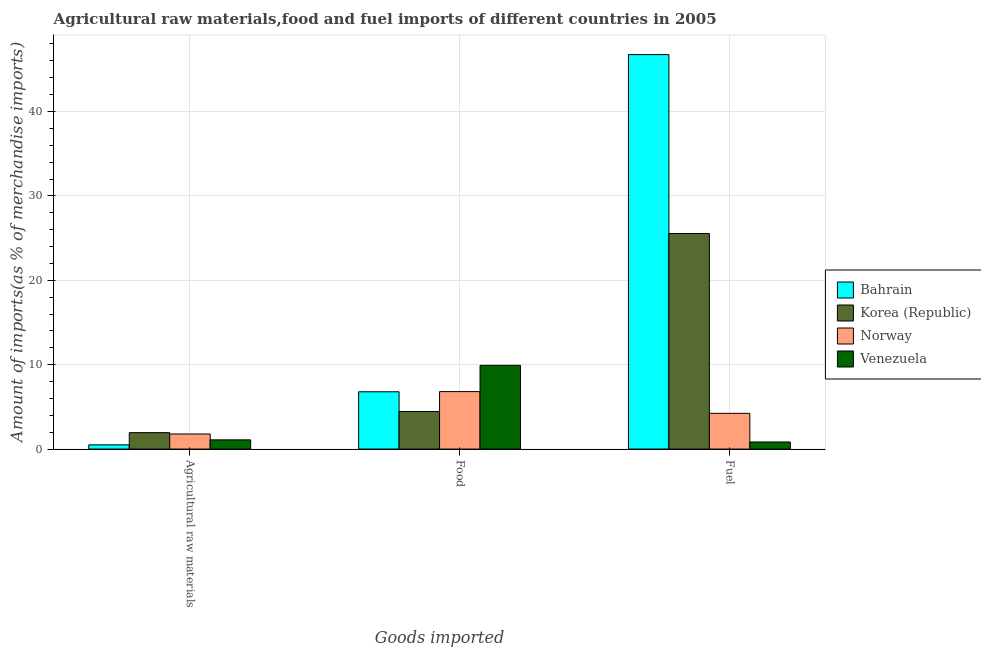How many groups of bars are there?
Keep it short and to the point. 3. How many bars are there on the 2nd tick from the right?
Offer a very short reply. 4. What is the label of the 1st group of bars from the left?
Your response must be concise. Agricultural raw materials. What is the percentage of raw materials imports in Bahrain?
Offer a terse response. 0.5. Across all countries, what is the maximum percentage of fuel imports?
Make the answer very short. 46.74. Across all countries, what is the minimum percentage of fuel imports?
Provide a short and direct response. 0.84. In which country was the percentage of food imports maximum?
Your answer should be very brief. Venezuela. In which country was the percentage of raw materials imports minimum?
Give a very brief answer. Bahrain. What is the total percentage of fuel imports in the graph?
Ensure brevity in your answer.  77.36. What is the difference between the percentage of raw materials imports in Norway and that in Bahrain?
Your response must be concise. 1.29. What is the difference between the percentage of food imports in Bahrain and the percentage of raw materials imports in Venezuela?
Make the answer very short. 5.7. What is the average percentage of food imports per country?
Offer a very short reply. 6.99. What is the difference between the percentage of food imports and percentage of raw materials imports in Norway?
Give a very brief answer. 5.02. In how many countries, is the percentage of raw materials imports greater than 32 %?
Offer a very short reply. 0. What is the ratio of the percentage of raw materials imports in Bahrain to that in Korea (Republic)?
Make the answer very short. 0.26. Is the percentage of raw materials imports in Venezuela less than that in Korea (Republic)?
Provide a short and direct response. Yes. Is the difference between the percentage of raw materials imports in Norway and Korea (Republic) greater than the difference between the percentage of fuel imports in Norway and Korea (Republic)?
Provide a succinct answer. Yes. What is the difference between the highest and the second highest percentage of food imports?
Provide a succinct answer. 3.11. What is the difference between the highest and the lowest percentage of fuel imports?
Ensure brevity in your answer.  45.9. In how many countries, is the percentage of fuel imports greater than the average percentage of fuel imports taken over all countries?
Provide a succinct answer. 2. What does the 4th bar from the left in Agricultural raw materials represents?
Give a very brief answer. Venezuela. How many bars are there?
Your response must be concise. 12. Are all the bars in the graph horizontal?
Give a very brief answer. No. How many countries are there in the graph?
Keep it short and to the point. 4. Are the values on the major ticks of Y-axis written in scientific E-notation?
Provide a short and direct response. No. Does the graph contain any zero values?
Offer a terse response. No. How many legend labels are there?
Ensure brevity in your answer.  4. How are the legend labels stacked?
Provide a short and direct response. Vertical. What is the title of the graph?
Offer a terse response. Agricultural raw materials,food and fuel imports of different countries in 2005. What is the label or title of the X-axis?
Provide a short and direct response. Goods imported. What is the label or title of the Y-axis?
Provide a short and direct response. Amount of imports(as % of merchandise imports). What is the Amount of imports(as % of merchandise imports) of Bahrain in Agricultural raw materials?
Keep it short and to the point. 0.5. What is the Amount of imports(as % of merchandise imports) in Korea (Republic) in Agricultural raw materials?
Ensure brevity in your answer.  1.95. What is the Amount of imports(as % of merchandise imports) in Norway in Agricultural raw materials?
Your answer should be compact. 1.79. What is the Amount of imports(as % of merchandise imports) in Venezuela in Agricultural raw materials?
Provide a short and direct response. 1.09. What is the Amount of imports(as % of merchandise imports) in Bahrain in Food?
Provide a succinct answer. 6.79. What is the Amount of imports(as % of merchandise imports) of Korea (Republic) in Food?
Provide a succinct answer. 4.45. What is the Amount of imports(as % of merchandise imports) in Norway in Food?
Offer a terse response. 6.81. What is the Amount of imports(as % of merchandise imports) in Venezuela in Food?
Offer a very short reply. 9.92. What is the Amount of imports(as % of merchandise imports) in Bahrain in Fuel?
Offer a terse response. 46.74. What is the Amount of imports(as % of merchandise imports) in Korea (Republic) in Fuel?
Offer a terse response. 25.54. What is the Amount of imports(as % of merchandise imports) of Norway in Fuel?
Make the answer very short. 4.24. What is the Amount of imports(as % of merchandise imports) in Venezuela in Fuel?
Your answer should be compact. 0.84. Across all Goods imported, what is the maximum Amount of imports(as % of merchandise imports) of Bahrain?
Offer a very short reply. 46.74. Across all Goods imported, what is the maximum Amount of imports(as % of merchandise imports) of Korea (Republic)?
Ensure brevity in your answer.  25.54. Across all Goods imported, what is the maximum Amount of imports(as % of merchandise imports) of Norway?
Provide a short and direct response. 6.81. Across all Goods imported, what is the maximum Amount of imports(as % of merchandise imports) of Venezuela?
Give a very brief answer. 9.92. Across all Goods imported, what is the minimum Amount of imports(as % of merchandise imports) of Bahrain?
Offer a very short reply. 0.5. Across all Goods imported, what is the minimum Amount of imports(as % of merchandise imports) in Korea (Republic)?
Provide a short and direct response. 1.95. Across all Goods imported, what is the minimum Amount of imports(as % of merchandise imports) in Norway?
Provide a short and direct response. 1.79. Across all Goods imported, what is the minimum Amount of imports(as % of merchandise imports) in Venezuela?
Your answer should be very brief. 0.84. What is the total Amount of imports(as % of merchandise imports) of Bahrain in the graph?
Keep it short and to the point. 54.03. What is the total Amount of imports(as % of merchandise imports) in Korea (Republic) in the graph?
Offer a terse response. 31.95. What is the total Amount of imports(as % of merchandise imports) of Norway in the graph?
Give a very brief answer. 12.83. What is the total Amount of imports(as % of merchandise imports) of Venezuela in the graph?
Give a very brief answer. 11.86. What is the difference between the Amount of imports(as % of merchandise imports) of Bahrain in Agricultural raw materials and that in Food?
Your answer should be compact. -6.29. What is the difference between the Amount of imports(as % of merchandise imports) of Korea (Republic) in Agricultural raw materials and that in Food?
Provide a short and direct response. -2.51. What is the difference between the Amount of imports(as % of merchandise imports) in Norway in Agricultural raw materials and that in Food?
Offer a terse response. -5.02. What is the difference between the Amount of imports(as % of merchandise imports) of Venezuela in Agricultural raw materials and that in Food?
Provide a succinct answer. -8.83. What is the difference between the Amount of imports(as % of merchandise imports) of Bahrain in Agricultural raw materials and that in Fuel?
Ensure brevity in your answer.  -46.24. What is the difference between the Amount of imports(as % of merchandise imports) in Korea (Republic) in Agricultural raw materials and that in Fuel?
Your response must be concise. -23.6. What is the difference between the Amount of imports(as % of merchandise imports) in Norway in Agricultural raw materials and that in Fuel?
Keep it short and to the point. -2.45. What is the difference between the Amount of imports(as % of merchandise imports) of Venezuela in Agricultural raw materials and that in Fuel?
Offer a very short reply. 0.25. What is the difference between the Amount of imports(as % of merchandise imports) in Bahrain in Food and that in Fuel?
Offer a very short reply. -39.95. What is the difference between the Amount of imports(as % of merchandise imports) in Korea (Republic) in Food and that in Fuel?
Make the answer very short. -21.09. What is the difference between the Amount of imports(as % of merchandise imports) of Norway in Food and that in Fuel?
Keep it short and to the point. 2.58. What is the difference between the Amount of imports(as % of merchandise imports) in Venezuela in Food and that in Fuel?
Offer a very short reply. 9.08. What is the difference between the Amount of imports(as % of merchandise imports) of Bahrain in Agricultural raw materials and the Amount of imports(as % of merchandise imports) of Korea (Republic) in Food?
Your answer should be very brief. -3.95. What is the difference between the Amount of imports(as % of merchandise imports) of Bahrain in Agricultural raw materials and the Amount of imports(as % of merchandise imports) of Norway in Food?
Your response must be concise. -6.31. What is the difference between the Amount of imports(as % of merchandise imports) in Bahrain in Agricultural raw materials and the Amount of imports(as % of merchandise imports) in Venezuela in Food?
Keep it short and to the point. -9.42. What is the difference between the Amount of imports(as % of merchandise imports) of Korea (Republic) in Agricultural raw materials and the Amount of imports(as % of merchandise imports) of Norway in Food?
Keep it short and to the point. -4.86. What is the difference between the Amount of imports(as % of merchandise imports) of Korea (Republic) in Agricultural raw materials and the Amount of imports(as % of merchandise imports) of Venezuela in Food?
Ensure brevity in your answer.  -7.97. What is the difference between the Amount of imports(as % of merchandise imports) in Norway in Agricultural raw materials and the Amount of imports(as % of merchandise imports) in Venezuela in Food?
Offer a terse response. -8.14. What is the difference between the Amount of imports(as % of merchandise imports) of Bahrain in Agricultural raw materials and the Amount of imports(as % of merchandise imports) of Korea (Republic) in Fuel?
Provide a short and direct response. -25.04. What is the difference between the Amount of imports(as % of merchandise imports) of Bahrain in Agricultural raw materials and the Amount of imports(as % of merchandise imports) of Norway in Fuel?
Make the answer very short. -3.73. What is the difference between the Amount of imports(as % of merchandise imports) of Bahrain in Agricultural raw materials and the Amount of imports(as % of merchandise imports) of Venezuela in Fuel?
Provide a succinct answer. -0.34. What is the difference between the Amount of imports(as % of merchandise imports) in Korea (Republic) in Agricultural raw materials and the Amount of imports(as % of merchandise imports) in Norway in Fuel?
Provide a short and direct response. -2.29. What is the difference between the Amount of imports(as % of merchandise imports) of Korea (Republic) in Agricultural raw materials and the Amount of imports(as % of merchandise imports) of Venezuela in Fuel?
Provide a succinct answer. 1.11. What is the difference between the Amount of imports(as % of merchandise imports) in Norway in Agricultural raw materials and the Amount of imports(as % of merchandise imports) in Venezuela in Fuel?
Keep it short and to the point. 0.95. What is the difference between the Amount of imports(as % of merchandise imports) in Bahrain in Food and the Amount of imports(as % of merchandise imports) in Korea (Republic) in Fuel?
Ensure brevity in your answer.  -18.75. What is the difference between the Amount of imports(as % of merchandise imports) of Bahrain in Food and the Amount of imports(as % of merchandise imports) of Norway in Fuel?
Offer a very short reply. 2.55. What is the difference between the Amount of imports(as % of merchandise imports) of Bahrain in Food and the Amount of imports(as % of merchandise imports) of Venezuela in Fuel?
Your response must be concise. 5.95. What is the difference between the Amount of imports(as % of merchandise imports) of Korea (Republic) in Food and the Amount of imports(as % of merchandise imports) of Norway in Fuel?
Ensure brevity in your answer.  0.22. What is the difference between the Amount of imports(as % of merchandise imports) of Korea (Republic) in Food and the Amount of imports(as % of merchandise imports) of Venezuela in Fuel?
Your answer should be compact. 3.61. What is the difference between the Amount of imports(as % of merchandise imports) in Norway in Food and the Amount of imports(as % of merchandise imports) in Venezuela in Fuel?
Make the answer very short. 5.97. What is the average Amount of imports(as % of merchandise imports) of Bahrain per Goods imported?
Offer a very short reply. 18.01. What is the average Amount of imports(as % of merchandise imports) in Korea (Republic) per Goods imported?
Ensure brevity in your answer.  10.65. What is the average Amount of imports(as % of merchandise imports) in Norway per Goods imported?
Offer a terse response. 4.28. What is the average Amount of imports(as % of merchandise imports) in Venezuela per Goods imported?
Your answer should be very brief. 3.95. What is the difference between the Amount of imports(as % of merchandise imports) of Bahrain and Amount of imports(as % of merchandise imports) of Korea (Republic) in Agricultural raw materials?
Provide a succinct answer. -1.45. What is the difference between the Amount of imports(as % of merchandise imports) of Bahrain and Amount of imports(as % of merchandise imports) of Norway in Agricultural raw materials?
Your response must be concise. -1.29. What is the difference between the Amount of imports(as % of merchandise imports) in Bahrain and Amount of imports(as % of merchandise imports) in Venezuela in Agricultural raw materials?
Make the answer very short. -0.59. What is the difference between the Amount of imports(as % of merchandise imports) in Korea (Republic) and Amount of imports(as % of merchandise imports) in Norway in Agricultural raw materials?
Offer a very short reply. 0.16. What is the difference between the Amount of imports(as % of merchandise imports) in Korea (Republic) and Amount of imports(as % of merchandise imports) in Venezuela in Agricultural raw materials?
Your response must be concise. 0.85. What is the difference between the Amount of imports(as % of merchandise imports) in Norway and Amount of imports(as % of merchandise imports) in Venezuela in Agricultural raw materials?
Provide a succinct answer. 0.69. What is the difference between the Amount of imports(as % of merchandise imports) in Bahrain and Amount of imports(as % of merchandise imports) in Korea (Republic) in Food?
Your response must be concise. 2.33. What is the difference between the Amount of imports(as % of merchandise imports) in Bahrain and Amount of imports(as % of merchandise imports) in Norway in Food?
Your answer should be compact. -0.02. What is the difference between the Amount of imports(as % of merchandise imports) in Bahrain and Amount of imports(as % of merchandise imports) in Venezuela in Food?
Offer a terse response. -3.13. What is the difference between the Amount of imports(as % of merchandise imports) of Korea (Republic) and Amount of imports(as % of merchandise imports) of Norway in Food?
Your answer should be compact. -2.36. What is the difference between the Amount of imports(as % of merchandise imports) in Korea (Republic) and Amount of imports(as % of merchandise imports) in Venezuela in Food?
Your answer should be compact. -5.47. What is the difference between the Amount of imports(as % of merchandise imports) in Norway and Amount of imports(as % of merchandise imports) in Venezuela in Food?
Offer a terse response. -3.11. What is the difference between the Amount of imports(as % of merchandise imports) of Bahrain and Amount of imports(as % of merchandise imports) of Korea (Republic) in Fuel?
Offer a very short reply. 21.2. What is the difference between the Amount of imports(as % of merchandise imports) of Bahrain and Amount of imports(as % of merchandise imports) of Norway in Fuel?
Make the answer very short. 42.51. What is the difference between the Amount of imports(as % of merchandise imports) in Bahrain and Amount of imports(as % of merchandise imports) in Venezuela in Fuel?
Offer a terse response. 45.9. What is the difference between the Amount of imports(as % of merchandise imports) of Korea (Republic) and Amount of imports(as % of merchandise imports) of Norway in Fuel?
Your answer should be compact. 21.31. What is the difference between the Amount of imports(as % of merchandise imports) of Korea (Republic) and Amount of imports(as % of merchandise imports) of Venezuela in Fuel?
Your answer should be compact. 24.7. What is the difference between the Amount of imports(as % of merchandise imports) of Norway and Amount of imports(as % of merchandise imports) of Venezuela in Fuel?
Ensure brevity in your answer.  3.39. What is the ratio of the Amount of imports(as % of merchandise imports) in Bahrain in Agricultural raw materials to that in Food?
Offer a terse response. 0.07. What is the ratio of the Amount of imports(as % of merchandise imports) of Korea (Republic) in Agricultural raw materials to that in Food?
Ensure brevity in your answer.  0.44. What is the ratio of the Amount of imports(as % of merchandise imports) in Norway in Agricultural raw materials to that in Food?
Offer a terse response. 0.26. What is the ratio of the Amount of imports(as % of merchandise imports) of Venezuela in Agricultural raw materials to that in Food?
Provide a succinct answer. 0.11. What is the ratio of the Amount of imports(as % of merchandise imports) of Bahrain in Agricultural raw materials to that in Fuel?
Offer a very short reply. 0.01. What is the ratio of the Amount of imports(as % of merchandise imports) in Korea (Republic) in Agricultural raw materials to that in Fuel?
Keep it short and to the point. 0.08. What is the ratio of the Amount of imports(as % of merchandise imports) in Norway in Agricultural raw materials to that in Fuel?
Provide a short and direct response. 0.42. What is the ratio of the Amount of imports(as % of merchandise imports) in Venezuela in Agricultural raw materials to that in Fuel?
Provide a short and direct response. 1.3. What is the ratio of the Amount of imports(as % of merchandise imports) of Bahrain in Food to that in Fuel?
Ensure brevity in your answer.  0.15. What is the ratio of the Amount of imports(as % of merchandise imports) of Korea (Republic) in Food to that in Fuel?
Keep it short and to the point. 0.17. What is the ratio of the Amount of imports(as % of merchandise imports) of Norway in Food to that in Fuel?
Offer a terse response. 1.61. What is the ratio of the Amount of imports(as % of merchandise imports) of Venezuela in Food to that in Fuel?
Ensure brevity in your answer.  11.8. What is the difference between the highest and the second highest Amount of imports(as % of merchandise imports) of Bahrain?
Offer a terse response. 39.95. What is the difference between the highest and the second highest Amount of imports(as % of merchandise imports) of Korea (Republic)?
Keep it short and to the point. 21.09. What is the difference between the highest and the second highest Amount of imports(as % of merchandise imports) in Norway?
Offer a terse response. 2.58. What is the difference between the highest and the second highest Amount of imports(as % of merchandise imports) of Venezuela?
Your answer should be very brief. 8.83. What is the difference between the highest and the lowest Amount of imports(as % of merchandise imports) in Bahrain?
Offer a terse response. 46.24. What is the difference between the highest and the lowest Amount of imports(as % of merchandise imports) in Korea (Republic)?
Provide a short and direct response. 23.6. What is the difference between the highest and the lowest Amount of imports(as % of merchandise imports) of Norway?
Provide a succinct answer. 5.02. What is the difference between the highest and the lowest Amount of imports(as % of merchandise imports) in Venezuela?
Offer a terse response. 9.08. 